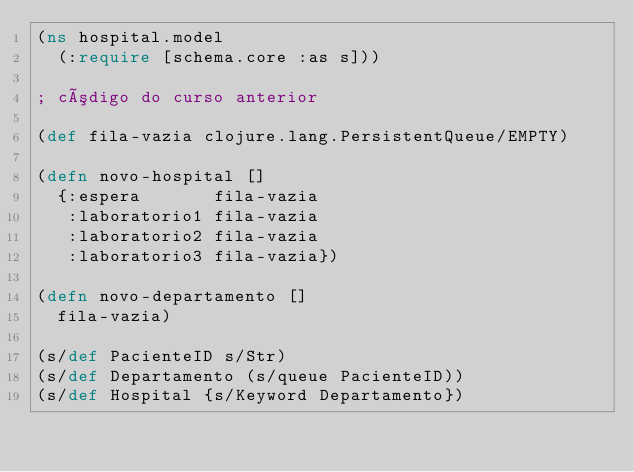<code> <loc_0><loc_0><loc_500><loc_500><_Clojure_>(ns hospital.model
  (:require [schema.core :as s]))

; código do curso anterior

(def fila-vazia clojure.lang.PersistentQueue/EMPTY)

(defn novo-hospital []
  {:espera       fila-vazia
   :laboratorio1 fila-vazia
   :laboratorio2 fila-vazia
   :laboratorio3 fila-vazia})

(defn novo-departamento []
  fila-vazia)

(s/def PacienteID s/Str)
(s/def Departamento (s/queue PacienteID))
(s/def Hospital {s/Keyword Departamento})
</code> 